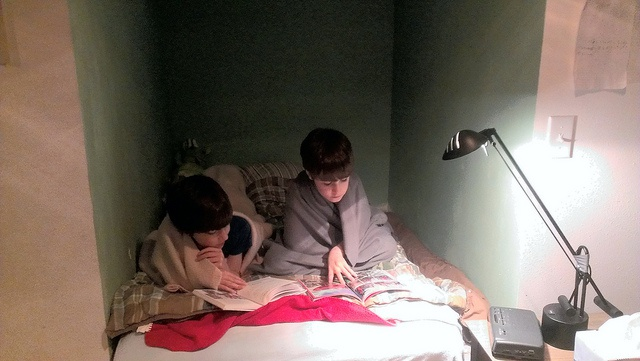Describe the objects in this image and their specific colors. I can see bed in brown, white, black, maroon, and pink tones, people in brown, black, gray, darkgray, and lightpink tones, people in brown, black, maroon, and salmon tones, book in brown, lightpink, gray, and salmon tones, and book in brown, lightgray, lightpink, and darkgray tones in this image. 